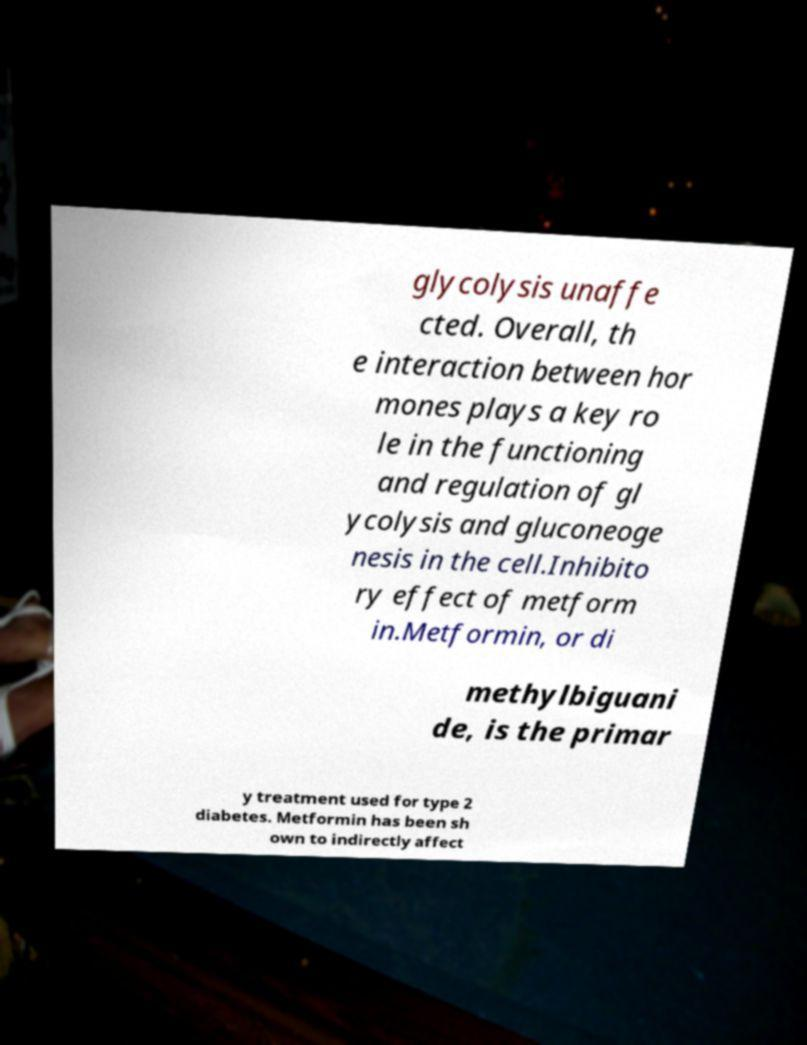What messages or text are displayed in this image? I need them in a readable, typed format. glycolysis unaffe cted. Overall, th e interaction between hor mones plays a key ro le in the functioning and regulation of gl ycolysis and gluconeoge nesis in the cell.Inhibito ry effect of metform in.Metformin, or di methylbiguani de, is the primar y treatment used for type 2 diabetes. Metformin has been sh own to indirectly affect 